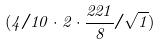<formula> <loc_0><loc_0><loc_500><loc_500>( 4 / 1 0 \cdot 2 \cdot \frac { 2 2 1 } { 8 } / \sqrt { 1 } )</formula> 